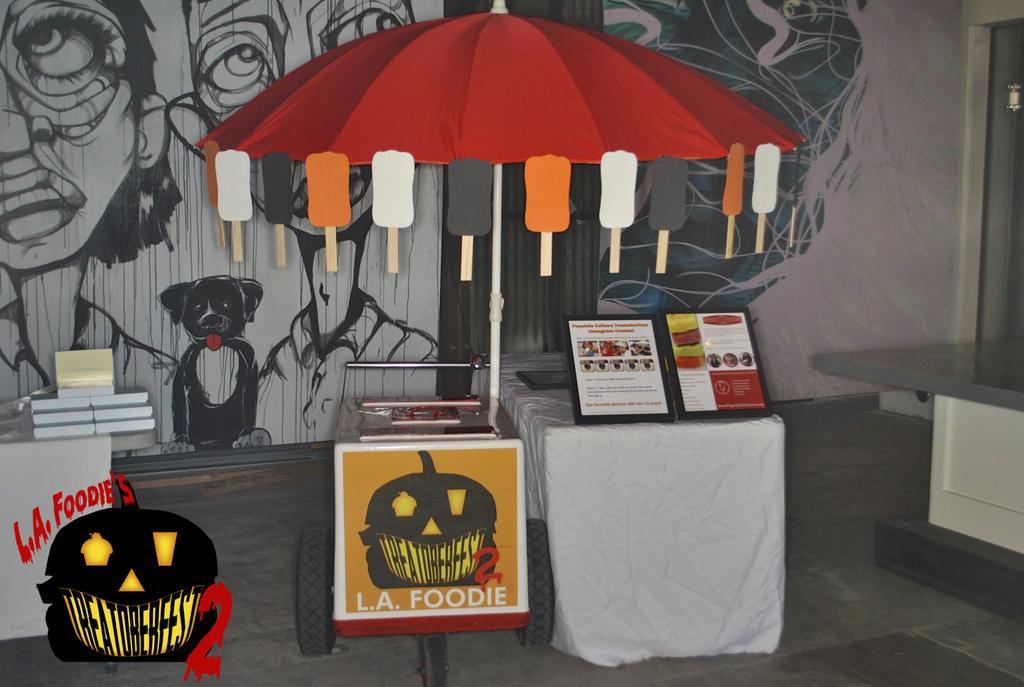Describe this image in one or two sentences. We can see ice creams with sticks on red color umbrella and we can see boards,books and objects on tables. Background we can see painting of persons and dog on a wall. This is floor. 